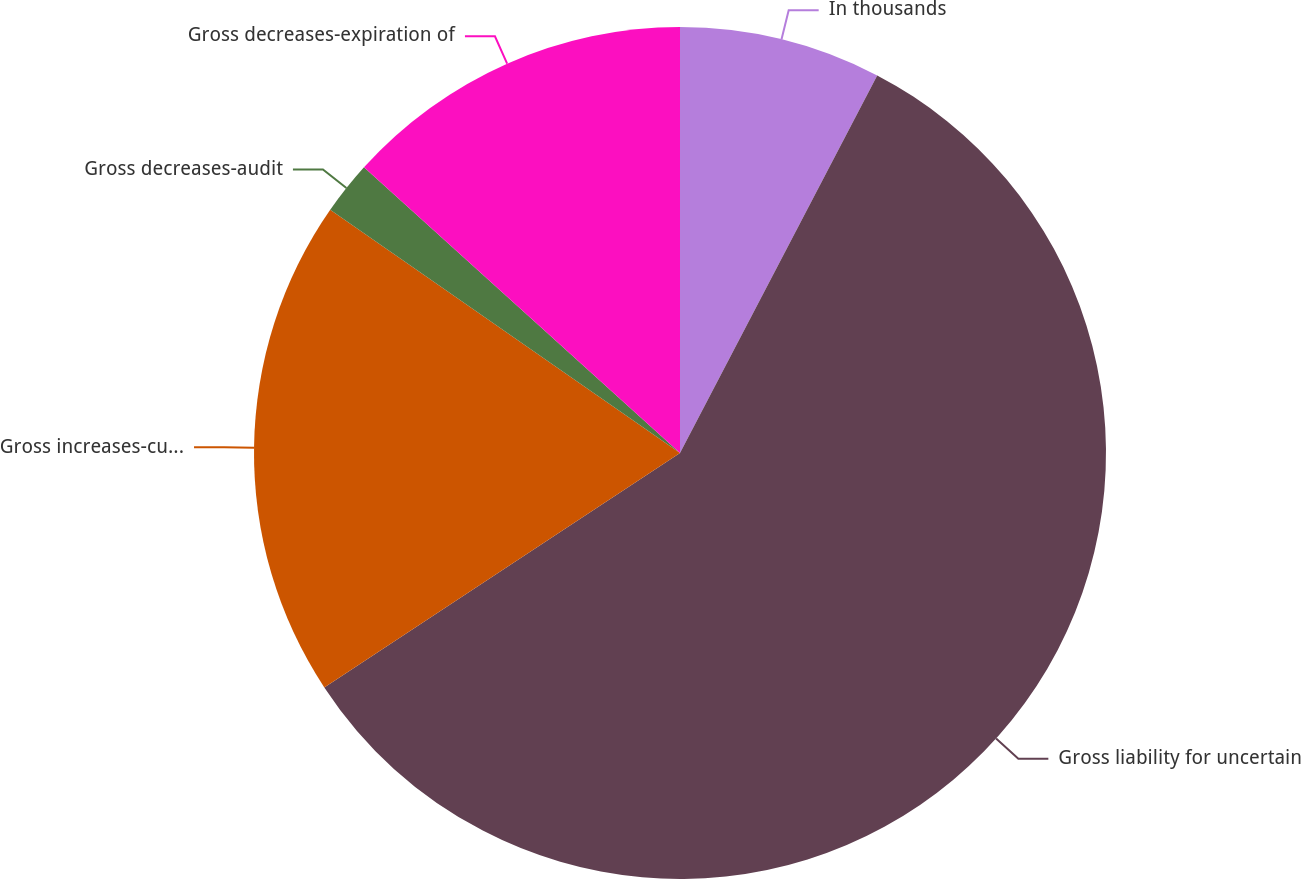Convert chart. <chart><loc_0><loc_0><loc_500><loc_500><pie_chart><fcel>In thousands<fcel>Gross liability for uncertain<fcel>Gross increases-current period<fcel>Gross decreases-audit<fcel>Gross decreases-expiration of<nl><fcel>7.66%<fcel>58.06%<fcel>18.94%<fcel>2.03%<fcel>13.3%<nl></chart> 